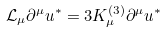<formula> <loc_0><loc_0><loc_500><loc_500>\mathcal { L } _ { \mu } \partial ^ { \mu } u ^ { * } = 3 K _ { \mu } ^ { ( 3 ) } \partial ^ { \mu } u ^ { * }</formula> 